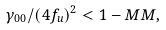Convert formula to latex. <formula><loc_0><loc_0><loc_500><loc_500>\gamma _ { 0 0 } / ( 4 f _ { u } ) ^ { 2 } < 1 - M M ,</formula> 